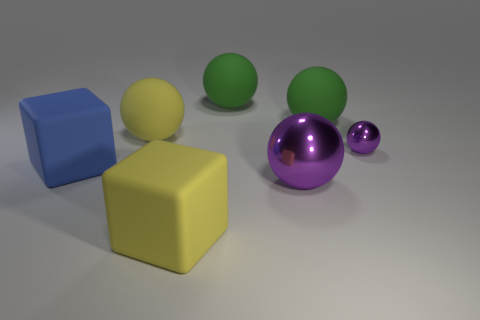How many spheres have the same material as the yellow block? Upon examining the image, it appears that there are two spheres sporting a matte finish that matches the yellow block's material. So, there are two spheres with the same material as the yellow block. 